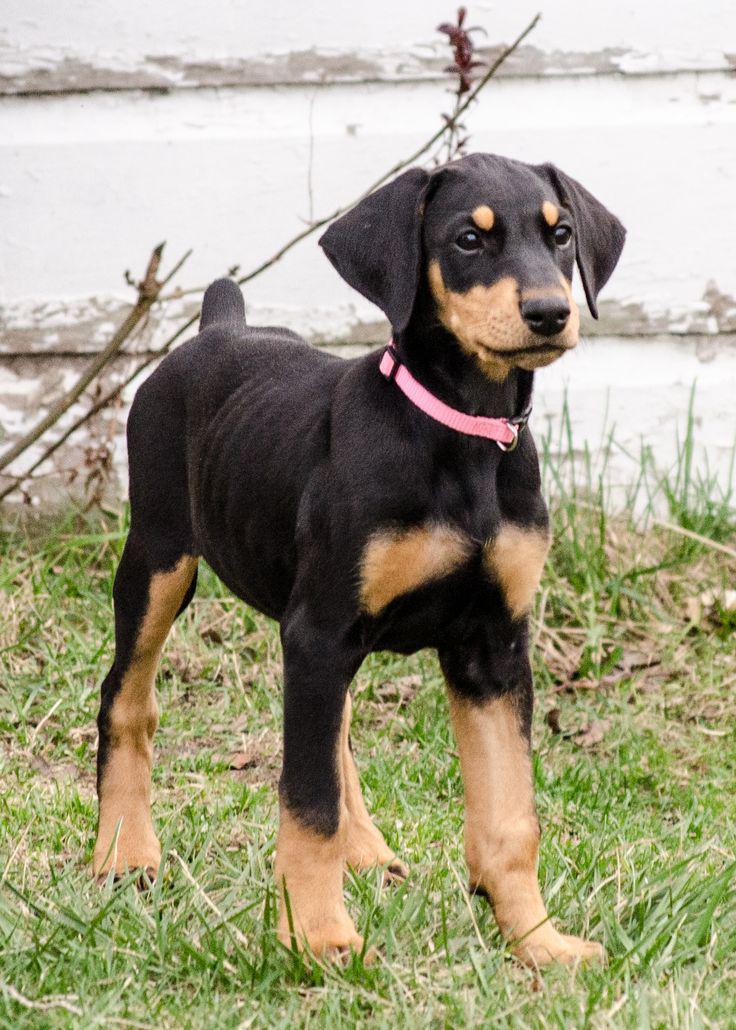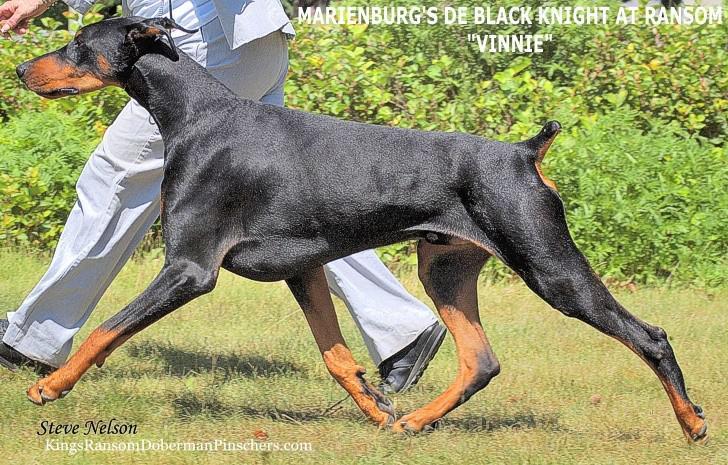The first image is the image on the left, the second image is the image on the right. Analyze the images presented: Is the assertion "One image is a full-grown dog and one is not." valid? Answer yes or no. Yes. The first image is the image on the left, the second image is the image on the right. Evaluate the accuracy of this statement regarding the images: "One image shows a single floppy-eared puppy in a standing pose, and the other image shows an adult dog in profile with its body turned leftward.". Is it true? Answer yes or no. Yes. 